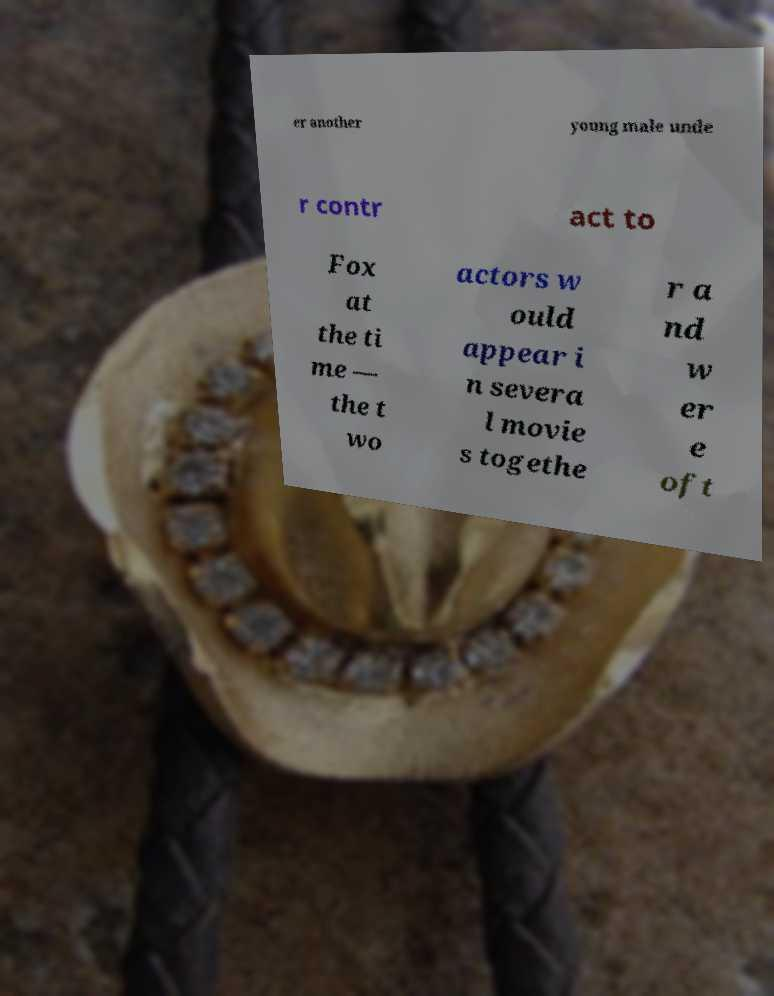Please identify and transcribe the text found in this image. er another young male unde r contr act to Fox at the ti me — the t wo actors w ould appear i n severa l movie s togethe r a nd w er e oft 